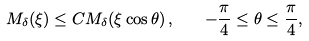<formula> <loc_0><loc_0><loc_500><loc_500>M _ { \delta } ( \xi ) \leq C M _ { \delta } ( \xi \cos \theta ) \, , \quad - \frac { \pi } { 4 } \leq \theta \leq \frac { \pi } { 4 } ,</formula> 